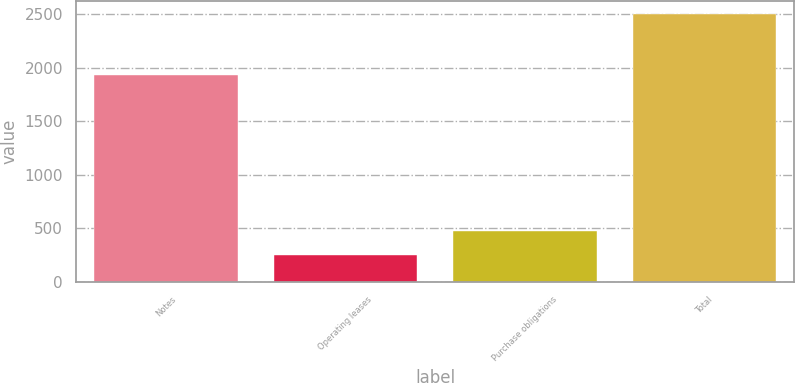Convert chart to OTSL. <chart><loc_0><loc_0><loc_500><loc_500><bar_chart><fcel>Notes<fcel>Operating leases<fcel>Purchase obligations<fcel>Total<nl><fcel>1931.7<fcel>251.2<fcel>476.05<fcel>2499.7<nl></chart> 